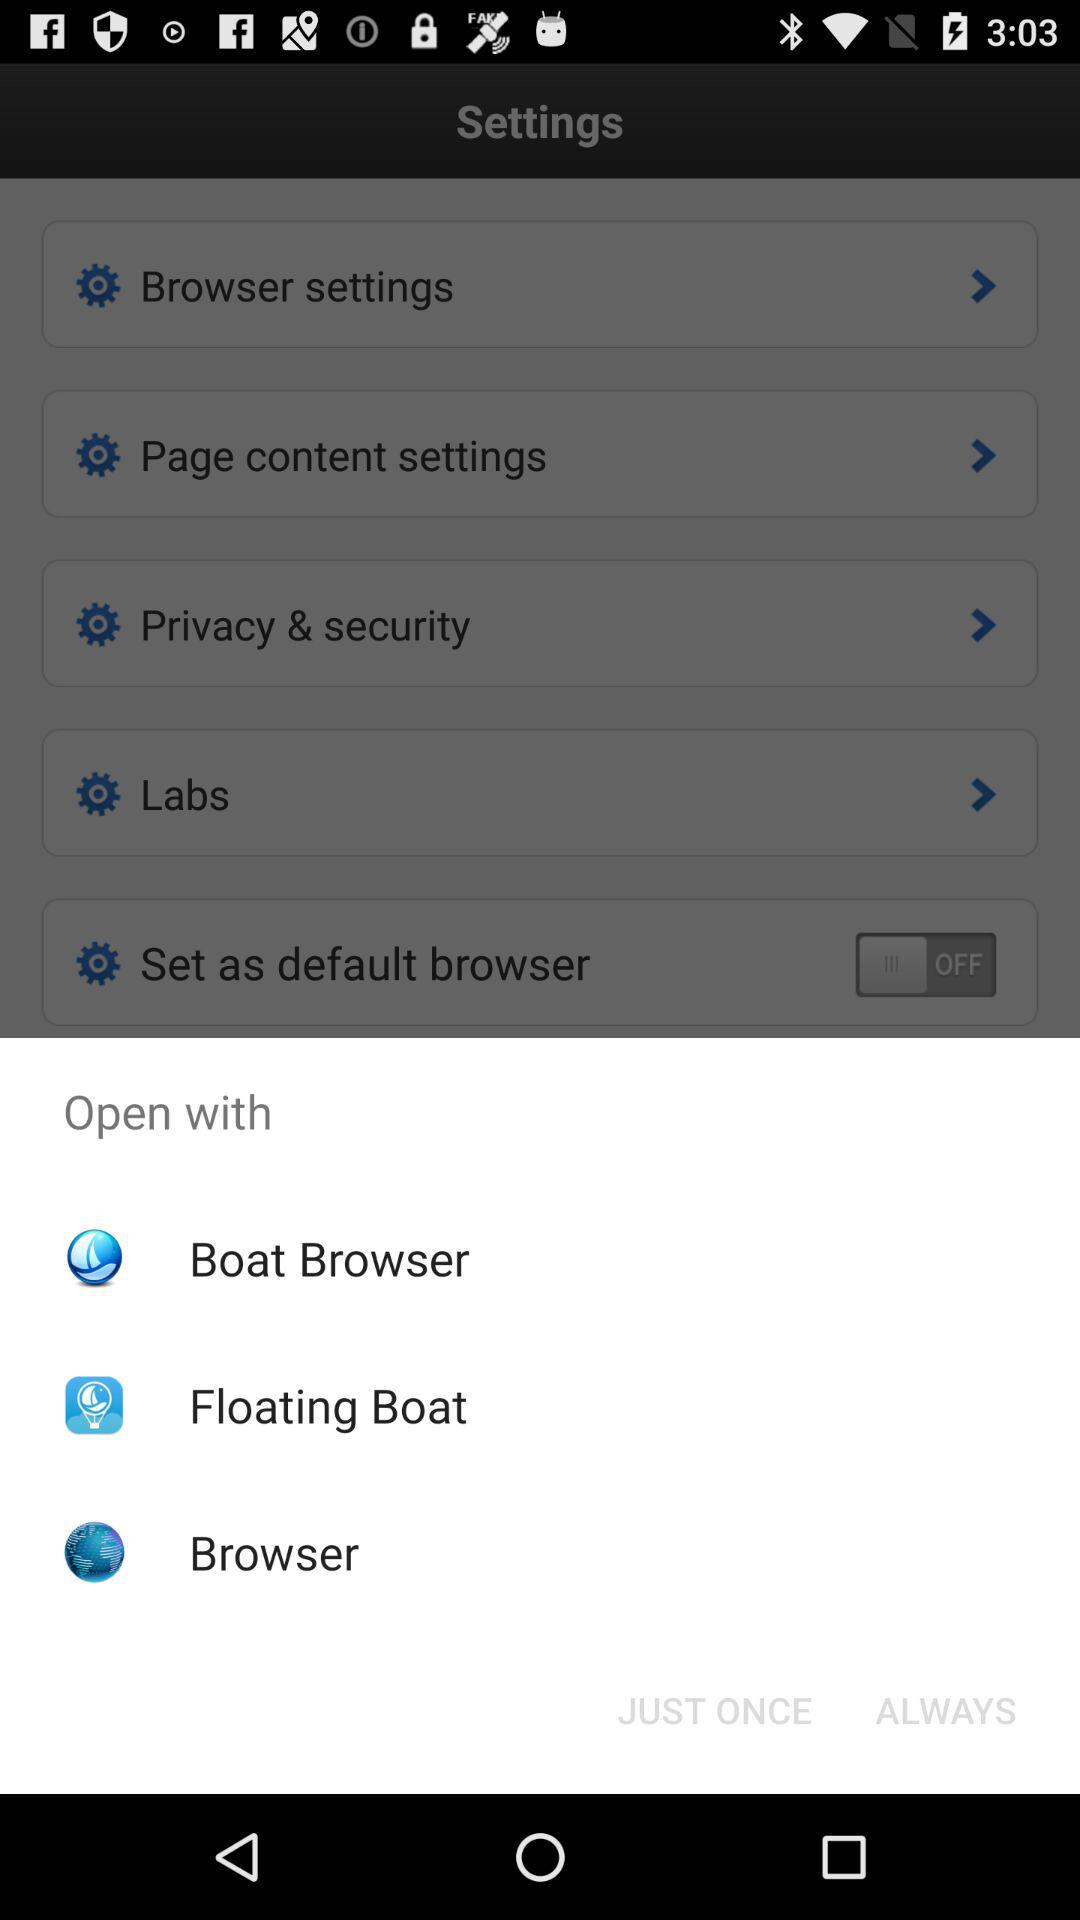Which application can be used to open the content? The applications that can be used to open the content are "Boat Browser", "Floating Boat" and "Browser". 